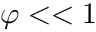<formula> <loc_0><loc_0><loc_500><loc_500>\varphi < < 1</formula> 